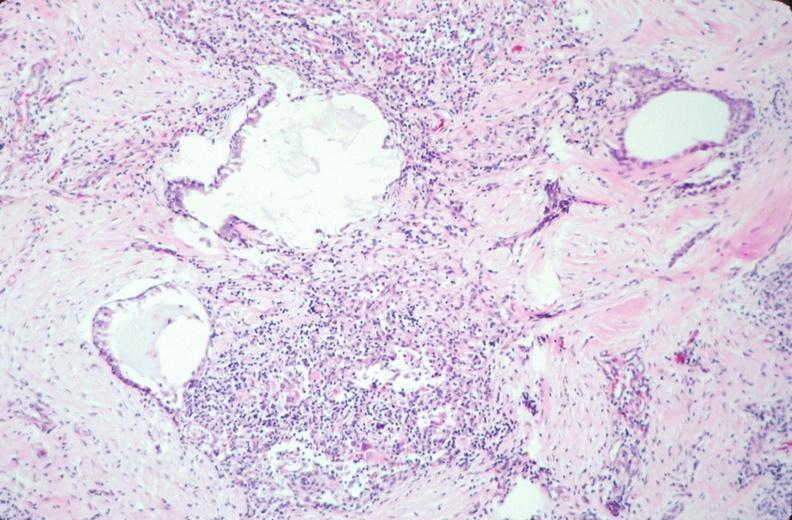what does this image show?
Answer the question using a single word or phrase. Pharyngeal pouch remnant 